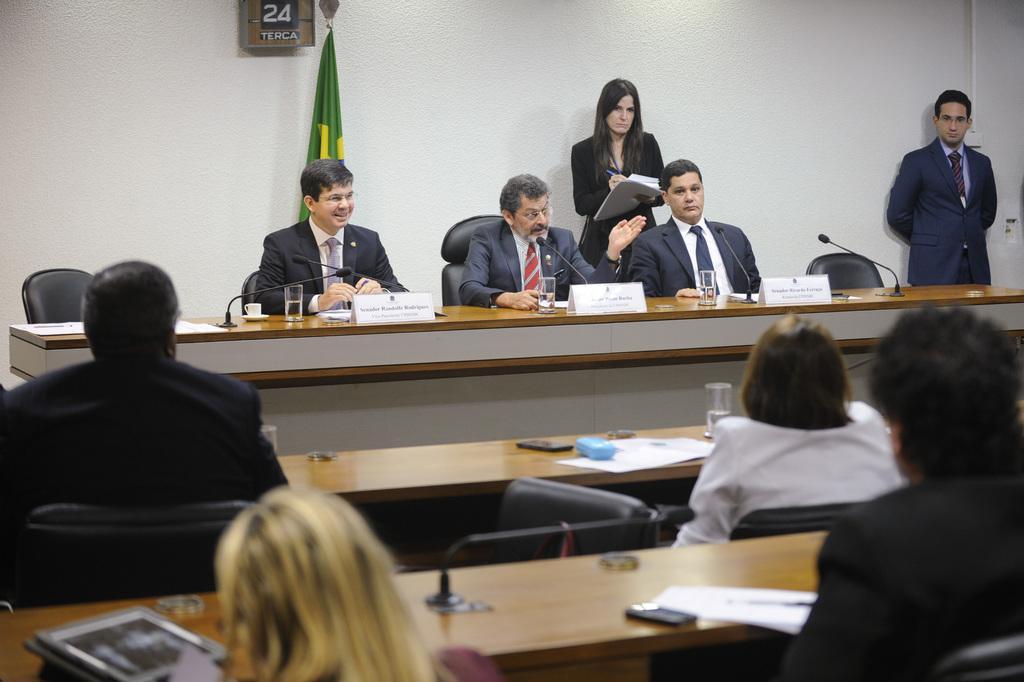Can you describe this image briefly? Here we can see a few people who are sitting on a chair and the person here is speaking on a microphone. 